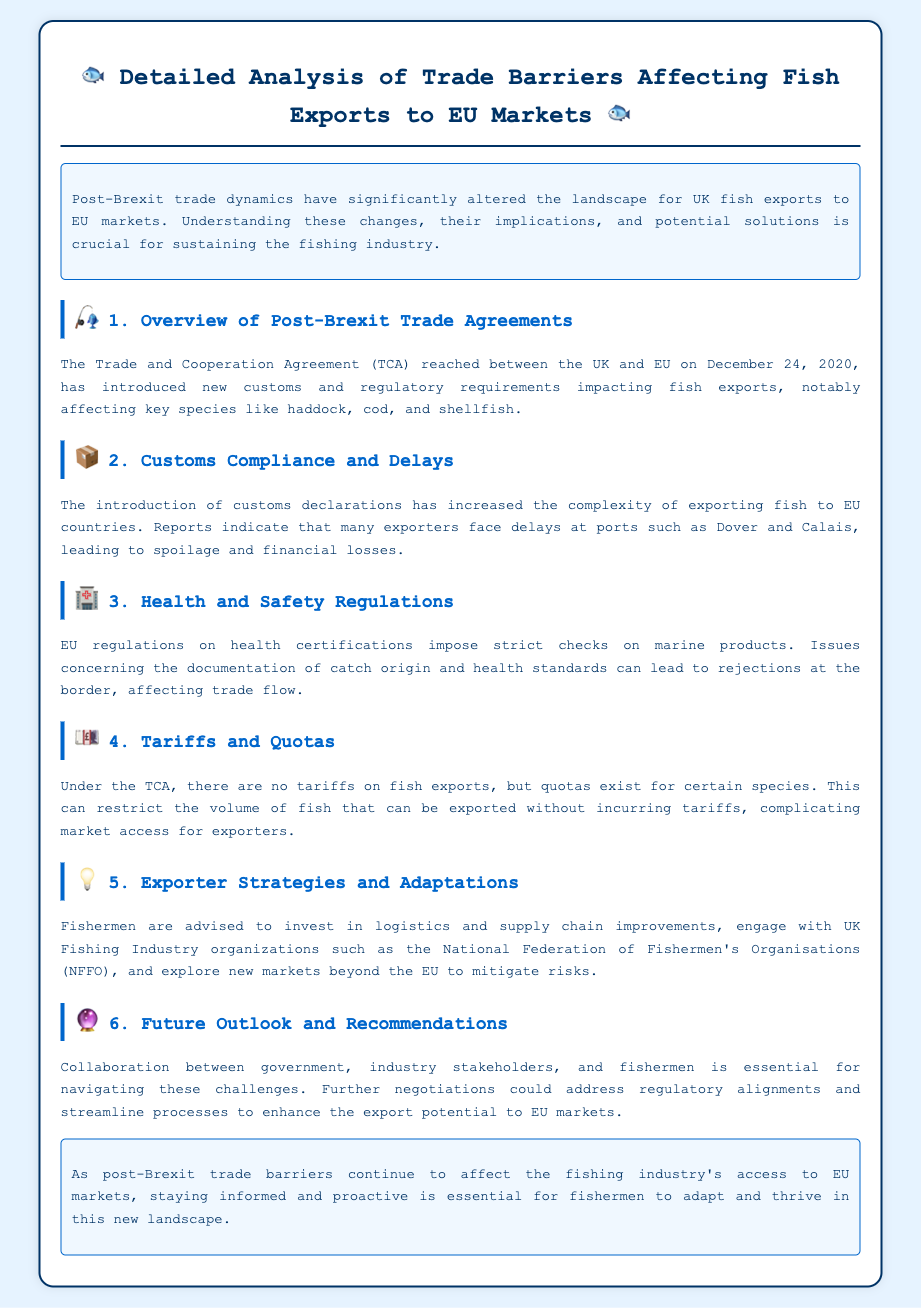What is the name of the agreement reached between the UK and EU? The agreement is referred to as the Trade and Cooperation Agreement (TCA).
Answer: Trade and Cooperation Agreement (TCA) What is a significant consequence of the new customs declarations? New customs declarations have increased the complexity of exporting fish, leading to delays and spoilage.
Answer: Delays and spoilage Which two fish species are notably affected by the trade barriers? The document highlights haddock and cod as key species impacted by trade barriers.
Answer: Haddock and cod What type of regulations have strict checks on marine products? EU regulations impose health and safety regulations on marine products.
Answer: Health and safety regulations What is advised for fishermen to mitigate risks? Fishermen are advised to invest in logistics and engage with industry organizations to mitigate risks.
Answer: Invest in logistics and engage with industry organizations How are future collaborations recommended to address issues? Collaboration between government, industry stakeholders, and fishermen is essential for navigating challenges.
Answer: Essential for navigating challenges What does the conclusion state about the importance of staying informed? The conclusion emphasizes that staying informed and proactive is essential for adapting to new trade barriers.
Answer: Essential for adapting to new trade barriers What is the section discussing tariffs and quotas about? The section addresses the absence of tariffs but the existence of quotas for certain exported fish species.
Answer: Absence of tariffs but existence of quotas 